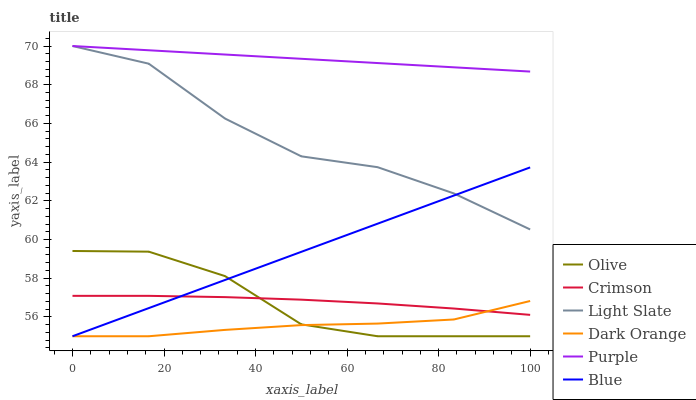Does Dark Orange have the minimum area under the curve?
Answer yes or no. Yes. Does Purple have the maximum area under the curve?
Answer yes or no. Yes. Does Purple have the minimum area under the curve?
Answer yes or no. No. Does Dark Orange have the maximum area under the curve?
Answer yes or no. No. Is Blue the smoothest?
Answer yes or no. Yes. Is Light Slate the roughest?
Answer yes or no. Yes. Is Dark Orange the smoothest?
Answer yes or no. No. Is Dark Orange the roughest?
Answer yes or no. No. Does Blue have the lowest value?
Answer yes or no. Yes. Does Purple have the lowest value?
Answer yes or no. No. Does Light Slate have the highest value?
Answer yes or no. Yes. Does Dark Orange have the highest value?
Answer yes or no. No. Is Crimson less than Light Slate?
Answer yes or no. Yes. Is Light Slate greater than Olive?
Answer yes or no. Yes. Does Crimson intersect Olive?
Answer yes or no. Yes. Is Crimson less than Olive?
Answer yes or no. No. Is Crimson greater than Olive?
Answer yes or no. No. Does Crimson intersect Light Slate?
Answer yes or no. No. 